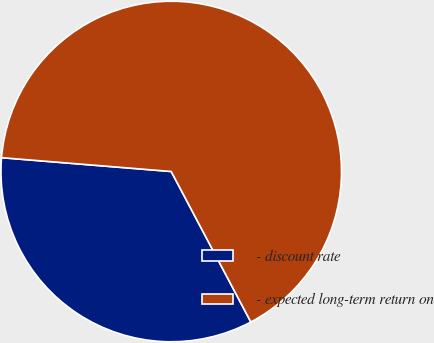Convert chart to OTSL. <chart><loc_0><loc_0><loc_500><loc_500><pie_chart><fcel>- discount rate<fcel>- expected long-term return on<nl><fcel>34.04%<fcel>65.96%<nl></chart> 